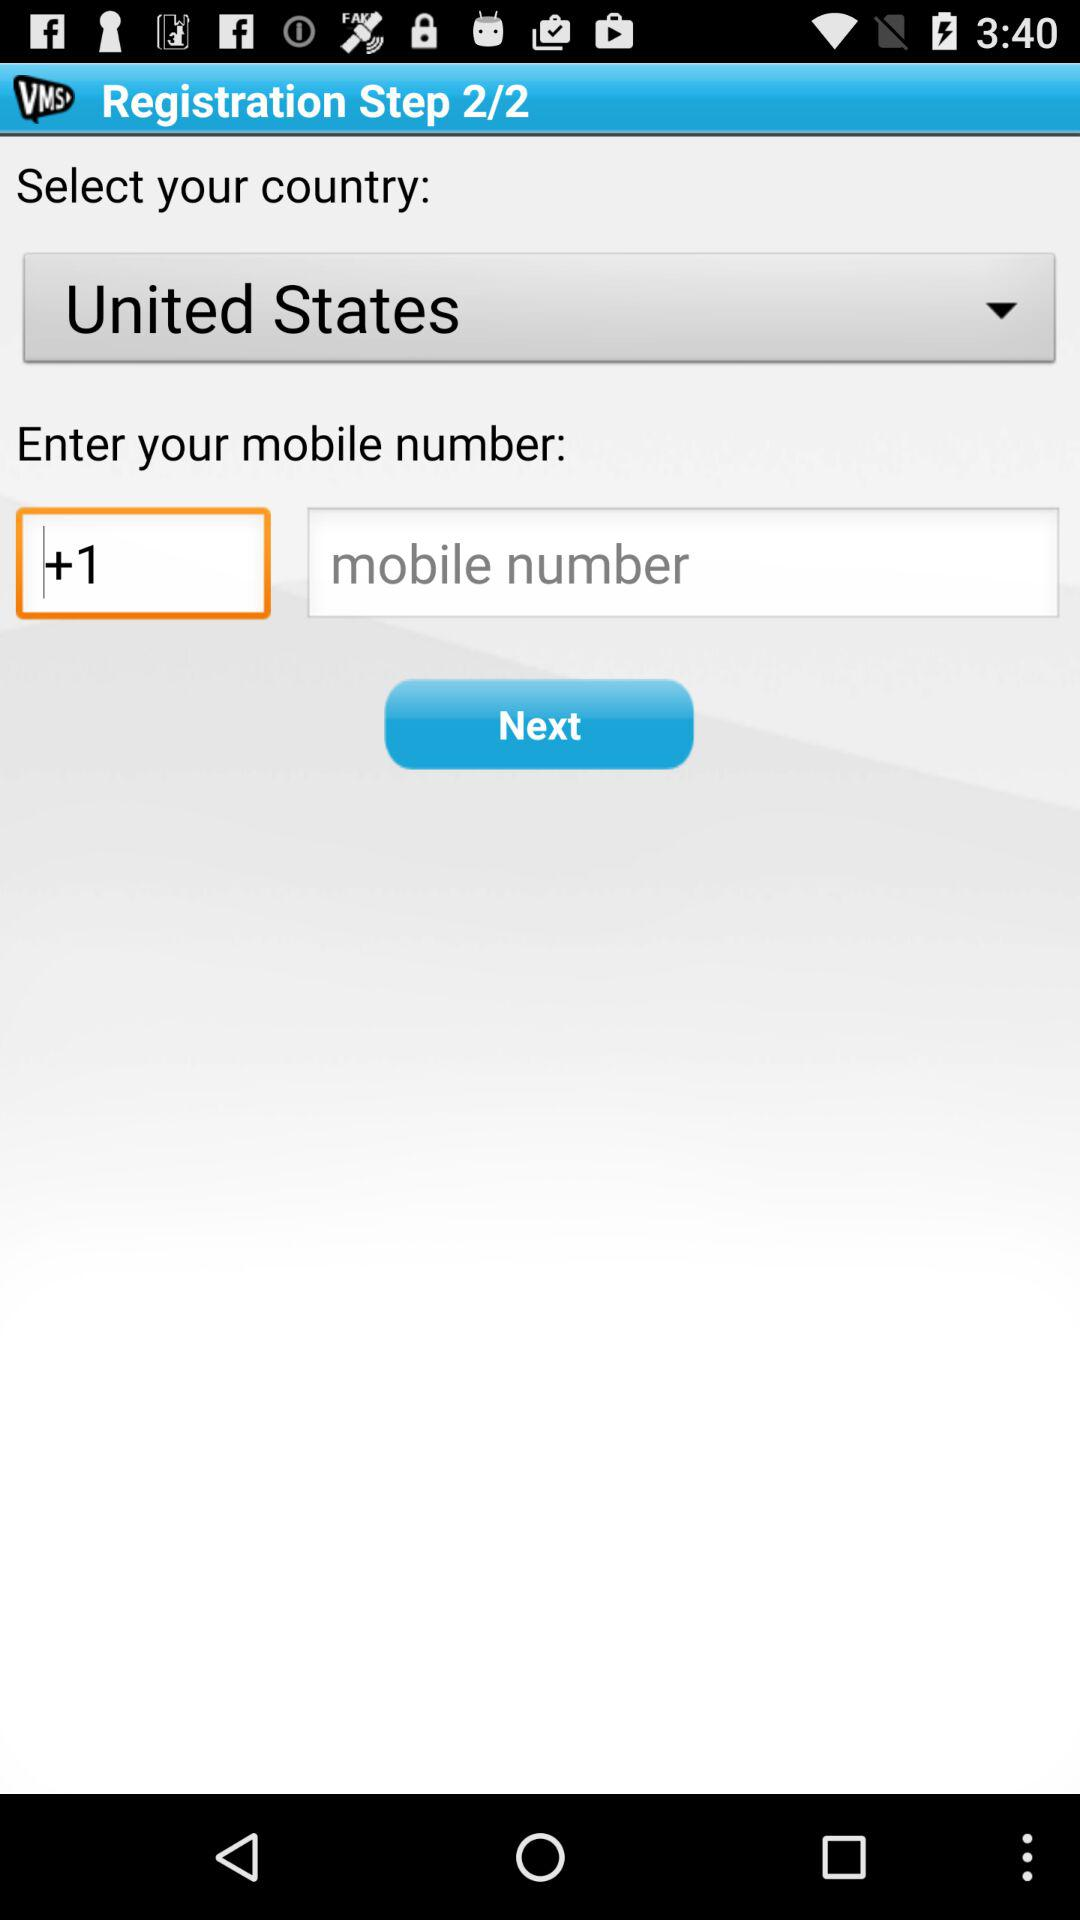How many steps are there for registration? There are 2 steps for registration. 